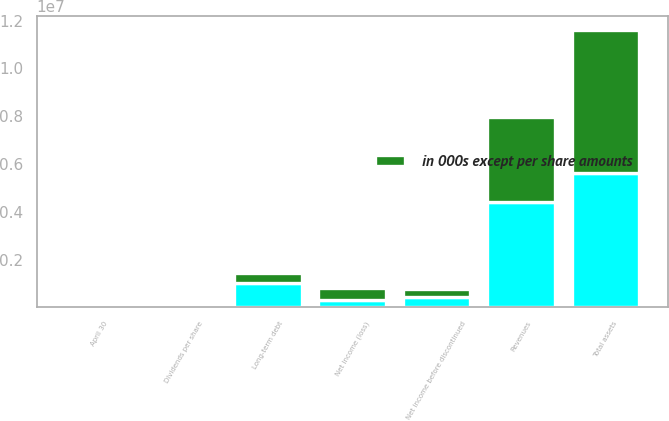Convert chart to OTSL. <chart><loc_0><loc_0><loc_500><loc_500><stacked_bar_chart><ecel><fcel>April 30<fcel>Revenues<fcel>Net income before discontinued<fcel>Net income (loss)<fcel>Total assets<fcel>Long-term debt<fcel>Dividends per share<nl><fcel>nan<fcel>2008<fcel>4.40388e+06<fcel>454476<fcel>308647<fcel>5.62342e+06<fcel>1.03178e+06<fcel>0.56<nl><fcel>in 000s except per share amounts<fcel>2006<fcel>3.57475e+06<fcel>297541<fcel>490408<fcel>5.98914e+06<fcel>417262<fcel>0.49<nl></chart> 